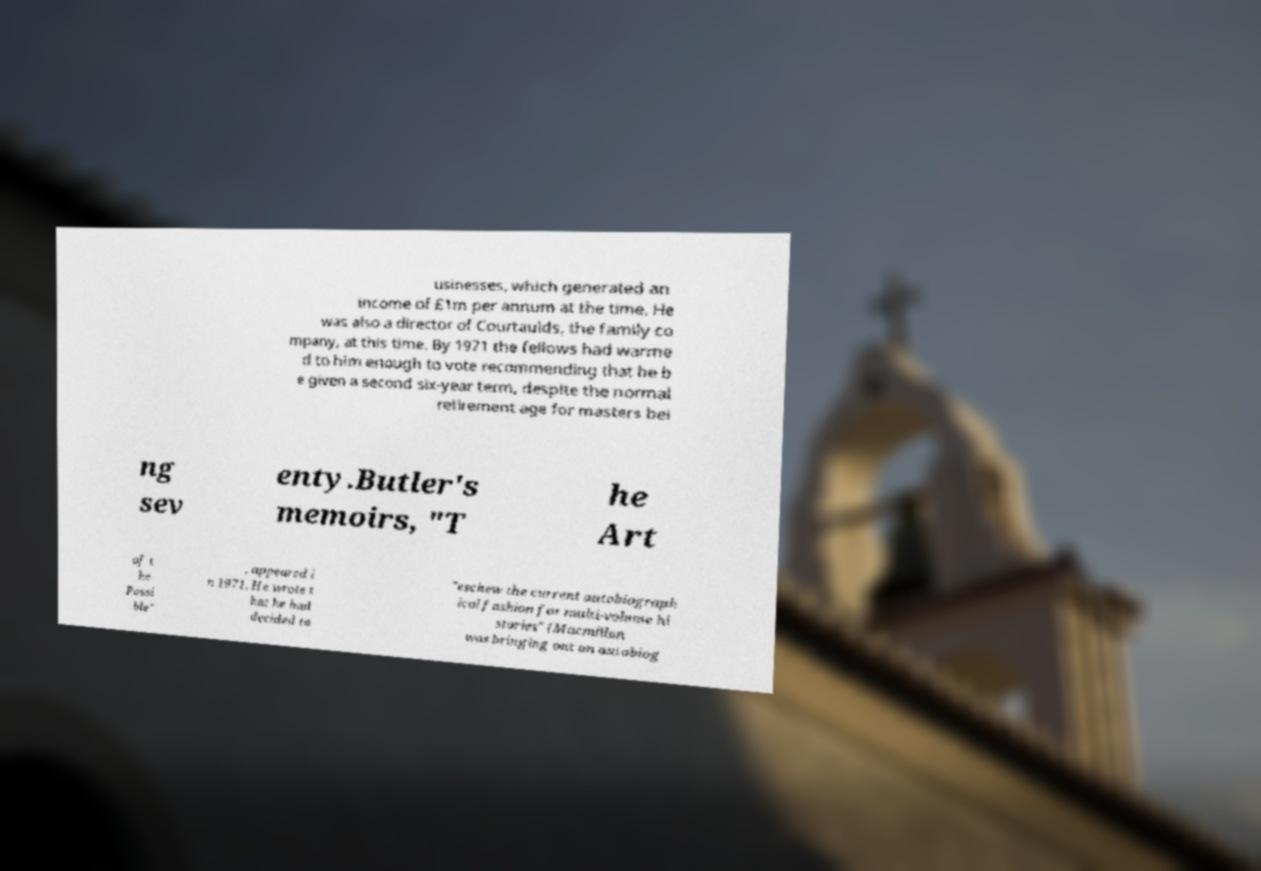Could you assist in decoding the text presented in this image and type it out clearly? usinesses, which generated an income of £1m per annum at the time. He was also a director of Courtaulds, the family co mpany, at this time. By 1971 the fellows had warme d to him enough to vote recommending that he b e given a second six-year term, despite the normal retirement age for masters bei ng sev enty.Butler's memoirs, "T he Art of t he Possi ble" , appeared i n 1971. He wrote t hat he had decided to "eschew the current autobiograph ical fashion for multi-volume hi stories" (Macmillan was bringing out an autobiog 